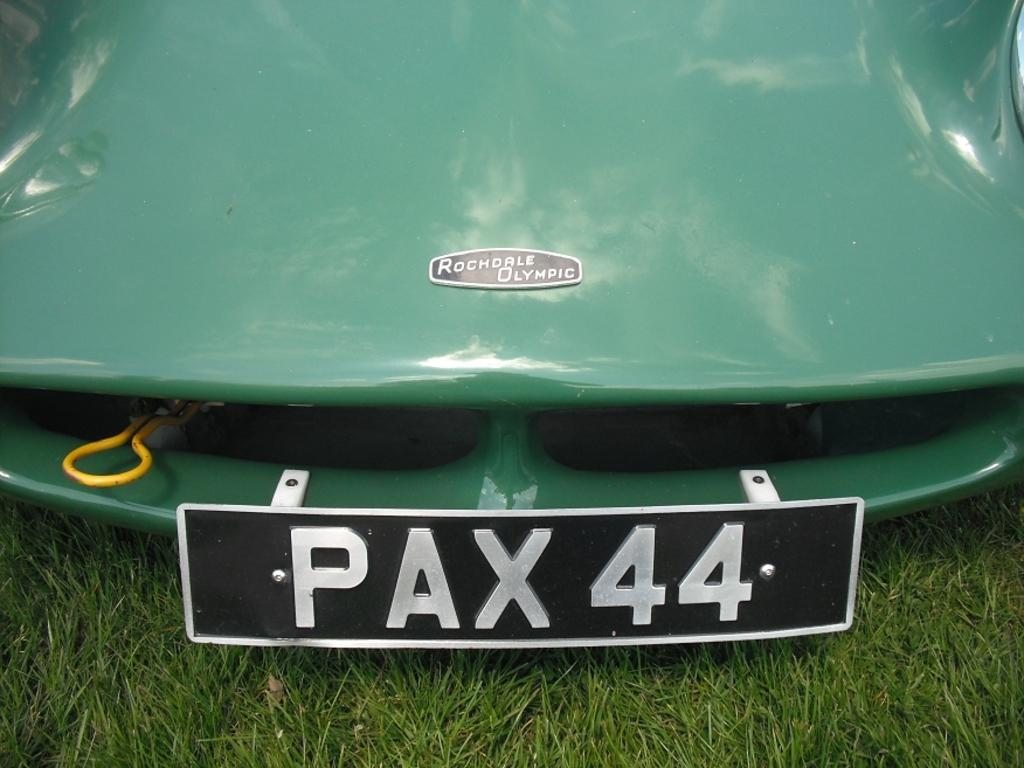<image>
Give a short and clear explanation of the subsequent image. A front of a green car has a plate on front stating pax 44. 